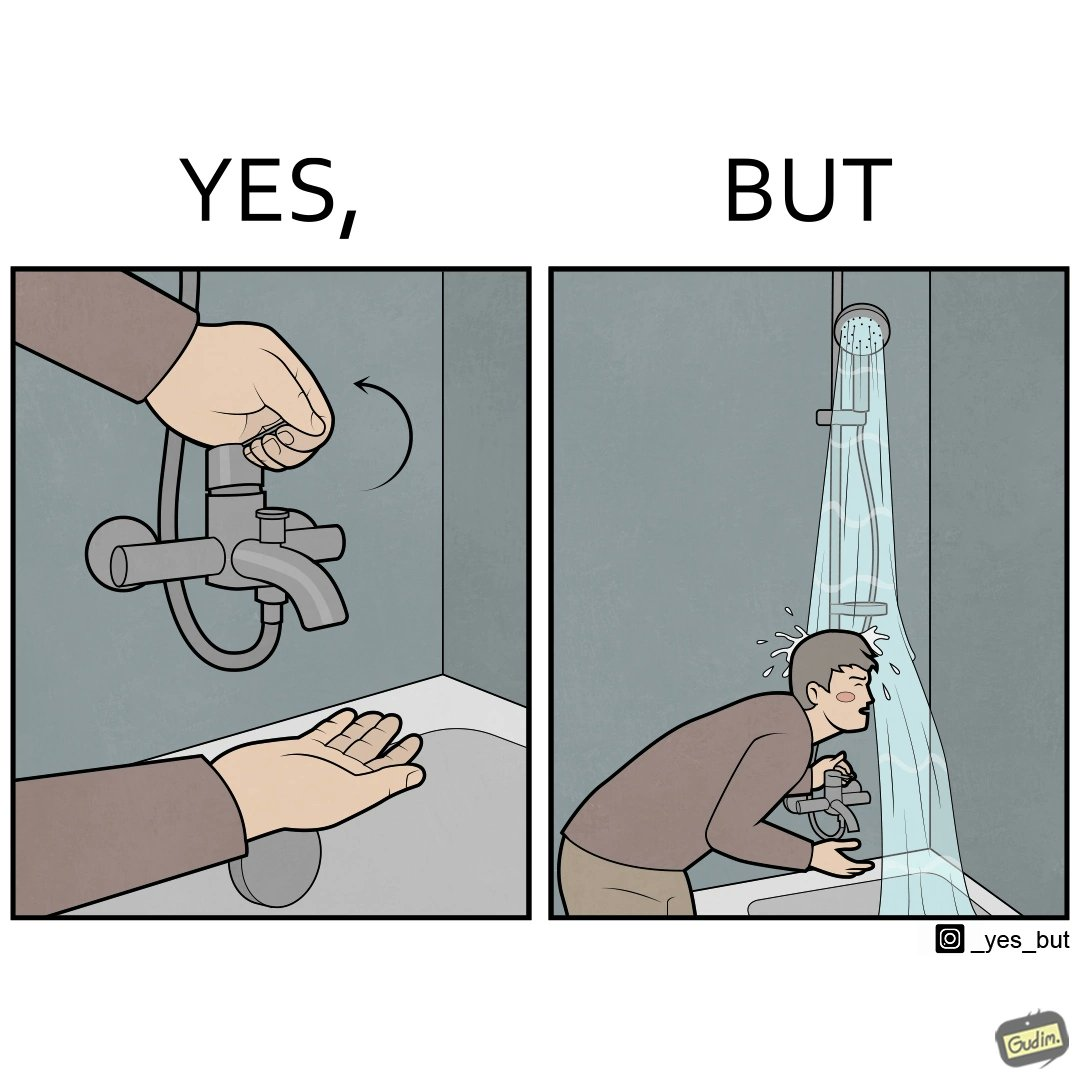What is shown in the left half versus the right half of this image? In the left part of the image: A person operating a tap on top of a bathtub. In the right part of the image: A person operating a tap on top of the bathtub, while water is pouring down on the person from the handheld shower rested upon a holder. 